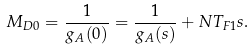<formula> <loc_0><loc_0><loc_500><loc_500>M _ { D 0 } = \frac { 1 } { g _ { A } ( 0 ) } = \frac { 1 } { g _ { A } ( s ) } + N T _ { F 1 } s .</formula> 